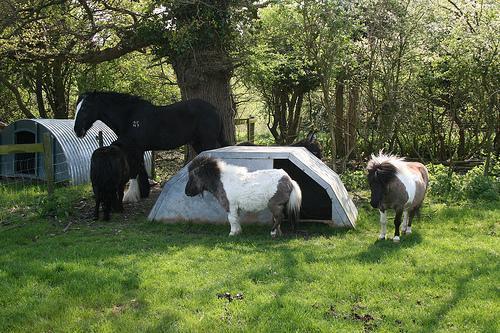How many big horse can be seen?
Give a very brief answer. 1. How many horses have white on them?
Give a very brief answer. 3. 